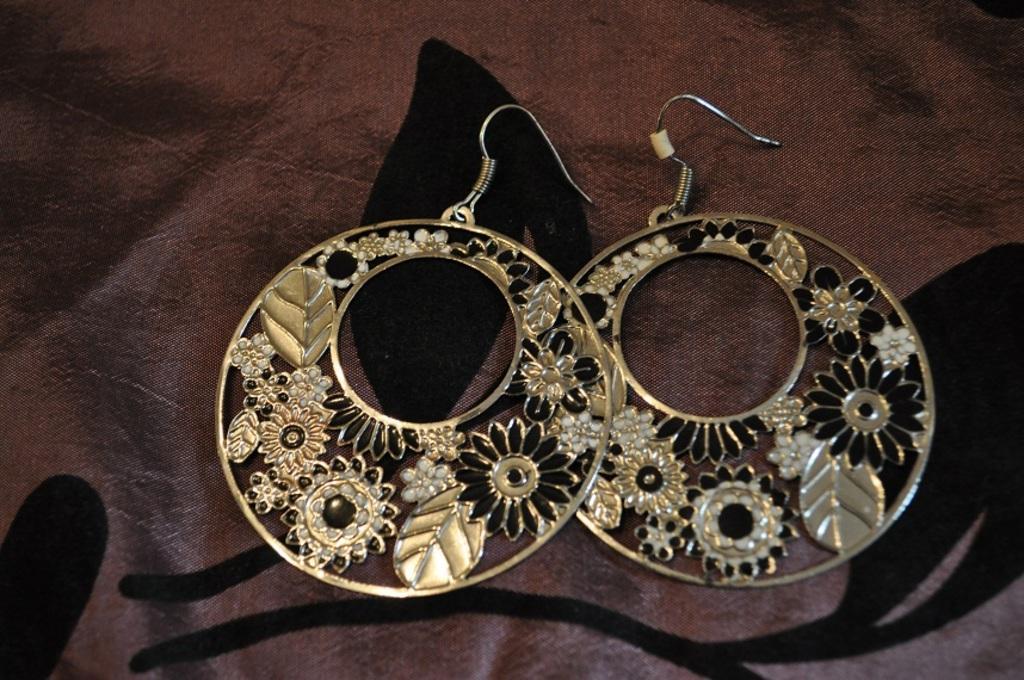Please provide a concise description of this image. In this picture there are earrings on the cloth. 